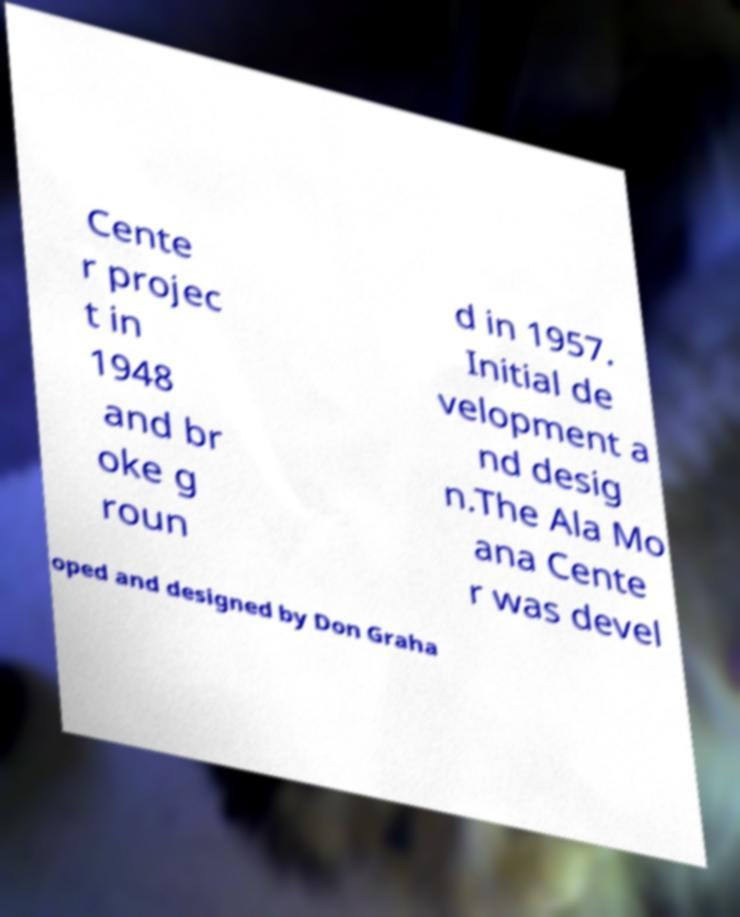Please read and relay the text visible in this image. What does it say? Cente r projec t in 1948 and br oke g roun d in 1957. Initial de velopment a nd desig n.The Ala Mo ana Cente r was devel oped and designed by Don Graha 